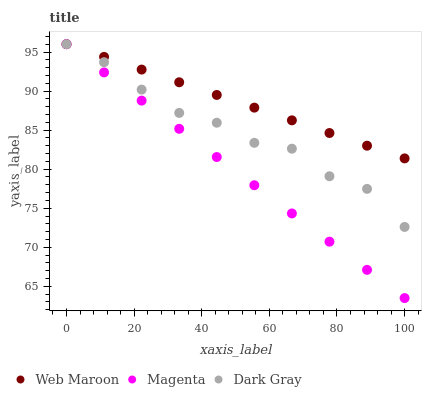Does Magenta have the minimum area under the curve?
Answer yes or no. Yes. Does Web Maroon have the maximum area under the curve?
Answer yes or no. Yes. Does Web Maroon have the minimum area under the curve?
Answer yes or no. No. Does Magenta have the maximum area under the curve?
Answer yes or no. No. Is Web Maroon the smoothest?
Answer yes or no. Yes. Is Dark Gray the roughest?
Answer yes or no. Yes. Is Magenta the smoothest?
Answer yes or no. No. Is Magenta the roughest?
Answer yes or no. No. Does Magenta have the lowest value?
Answer yes or no. Yes. Does Web Maroon have the lowest value?
Answer yes or no. No. Does Web Maroon have the highest value?
Answer yes or no. Yes. Does Dark Gray intersect Web Maroon?
Answer yes or no. Yes. Is Dark Gray less than Web Maroon?
Answer yes or no. No. Is Dark Gray greater than Web Maroon?
Answer yes or no. No. 